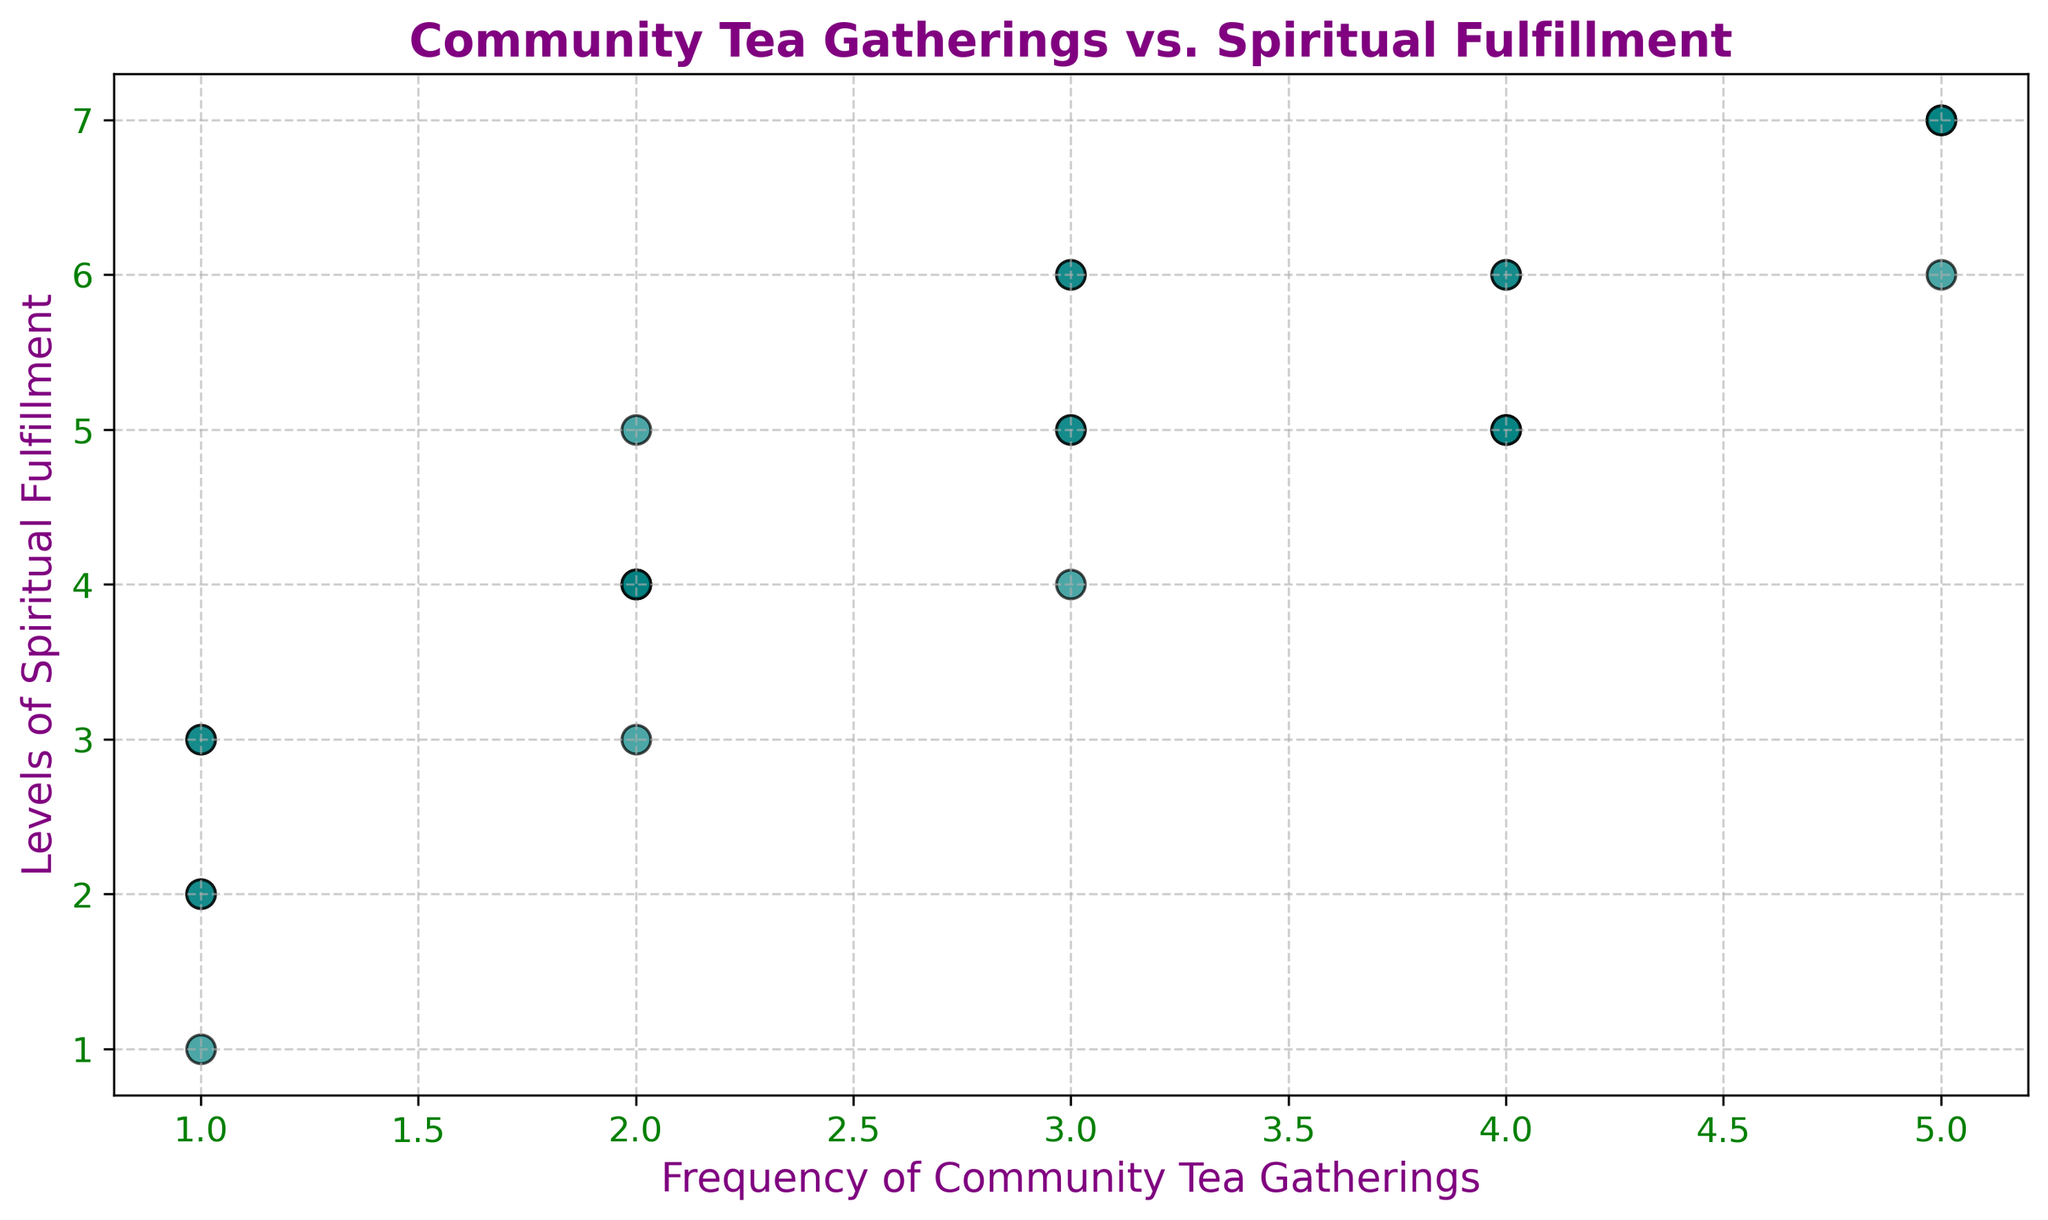What is the trend between the frequency of community tea gatherings and the levels of spiritual fulfillment? The scatter plot shows that as the frequency of tea gatherings increases (from 1 to 5), the levels of spiritual fulfillment generally increase (from 1 to 7). This indicates a positive trend between the two variables.
Answer: Positive What is the maximum level of spiritual fulfillment recorded? By observing the scatter plot, the highest level of spiritual fulfillment indicated on the y-axis is 7.
Answer: 7 How many data points represent participants who attend tea gatherings 3 times? By counting the data points at the frequency level of 3 on the x-axis, we can see four points, representing those attendees.
Answer: 4 Which frequency of community tea gatherings corresponds to the highest level of spiritual fulfillment? The highest level of spiritual fulfillment (7) corresponds to a frequency of 5 tea gatherings.
Answer: 5 Is there a frequency where spiritual fulfillment level is never above 4? By observing the scatter plot, the frequency of 1 gathering has all data points with a level of spiritual fulfillment below 4.
Answer: 1 What is the average level of spiritual fulfillment for participants attending 4 times? Participants attending 4 times have levels of 5, 6, 5, and 6. Adding these gives us 5 + 6 + 5 + 6 = 22. Dividing by 4 (number of points), the average level is 22/4 = 5.5.
Answer: 5.5 Compare the number of attendees with a spiritual fulfillment level of 5 to those of level 6. Which has more? By counting the scatter plot points, there are 5 attendees with a level of 5 and 4 attendees with a level of 6. Thus, level 5 has more attendees.
Answer: 5 Are there any outliers or unusual data points in the scatter plot? Observing the scatter plot, there are no visible outliers as all data points fall within a consistent pattern following the trend.
Answer: None What is the range of spiritual fulfillment levels for those with a frequency of 2 gatherings? For a frequency of 2, the levels are 4, 3, 5, 4, and 4. The range is calculated by subtracting the minimum value (3) from the maximum value (5), resulting in 5 - 3 = 2.
Answer: 2 How does the level of spiritual fulfillment for those attending 5 gatherings compare to those attending 1 gathering? For 1 gathering, the levels range from 1 to 3. For 5 gatherings, the levels range from 6 to 7. Therefore, levels of spiritual fulfillment are higher for those attending 5 gatherings compared to 1 gathering.
Answer: Higher for 5 gatherings 